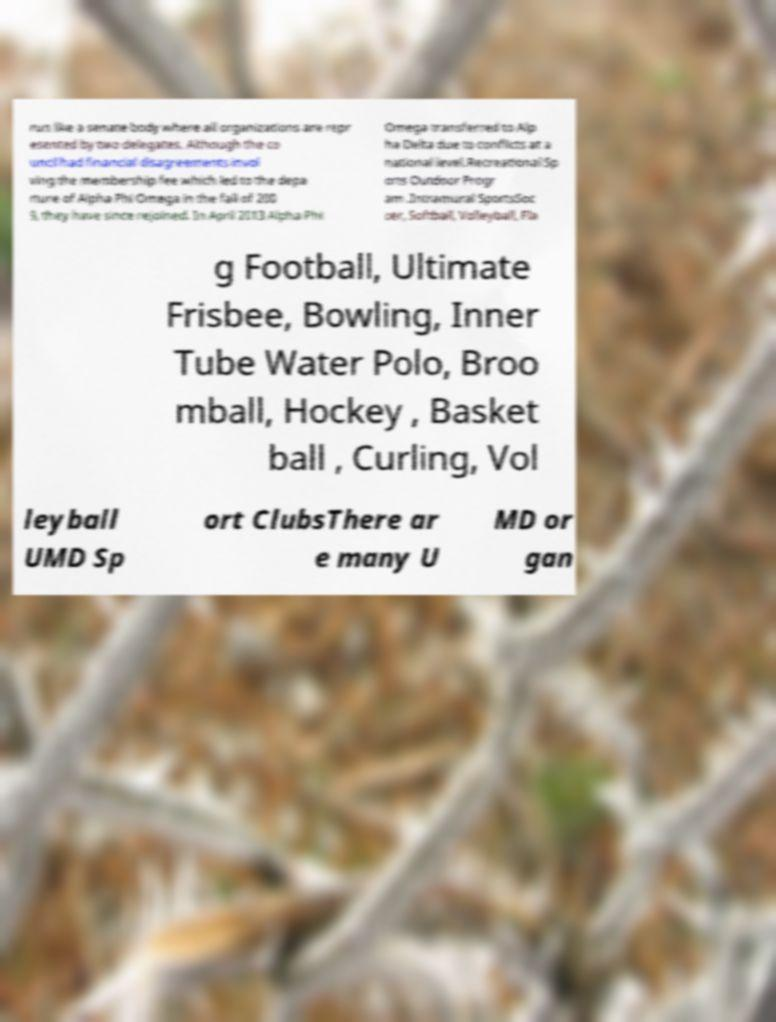For documentation purposes, I need the text within this image transcribed. Could you provide that? run like a senate body where all organizations are repr esented by two delegates. Although the co uncil had financial disagreements invol ving the membership fee which led to the depa rture of Alpha Phi Omega in the fall of 200 9, they have since rejoined. In April 2013 Alpha Phi Omega transferred to Alp ha Delta due to conflicts at a national level.Recreational Sp orts Outdoor Progr am .Intramural SportsSoc cer, Softball, Volleyball, Fla g Football, Ultimate Frisbee, Bowling, Inner Tube Water Polo, Broo mball, Hockey , Basket ball , Curling, Vol leyball UMD Sp ort ClubsThere ar e many U MD or gan 